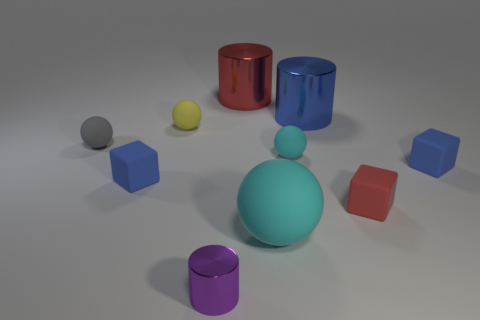Is the number of tiny objects to the left of the small gray sphere greater than the number of yellow spheres?
Provide a short and direct response. No. What is the gray sphere made of?
Your answer should be compact. Rubber. What number of gray spheres are the same size as the purple metallic object?
Your response must be concise. 1. Is the number of purple cylinders that are on the right side of the blue cylinder the same as the number of purple shiny cylinders behind the big red shiny object?
Make the answer very short. Yes. Are the small gray thing and the big blue cylinder made of the same material?
Make the answer very short. No. Is there a purple cylinder behind the blue matte object to the left of the large red cylinder?
Provide a short and direct response. No. Is there a big brown metallic object that has the same shape as the small yellow thing?
Your answer should be very brief. No. Does the large matte thing have the same color as the small metal object?
Make the answer very short. No. What is the red thing in front of the block that is to the left of the tiny yellow rubber sphere made of?
Provide a succinct answer. Rubber. The blue metal cylinder has what size?
Provide a succinct answer. Large. 